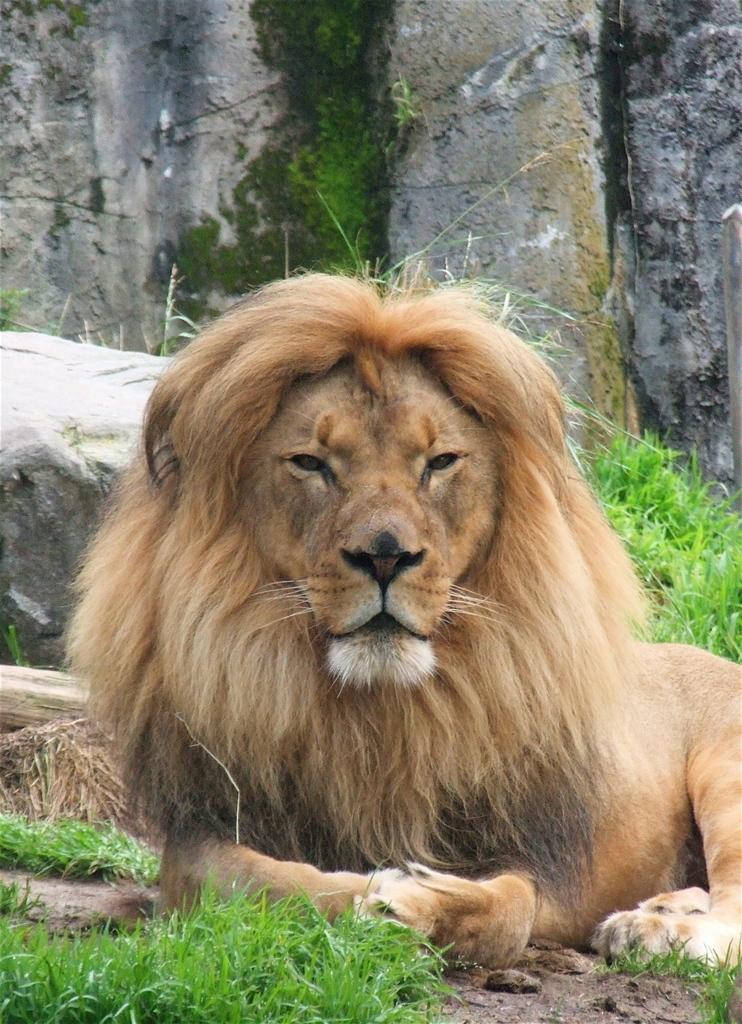How would you summarize this image in a sentence or two? In this image I can see a lion which is brown, cream and black in color is laying on the ground. I can see some grass on the ground and few rocks behind the lion. 